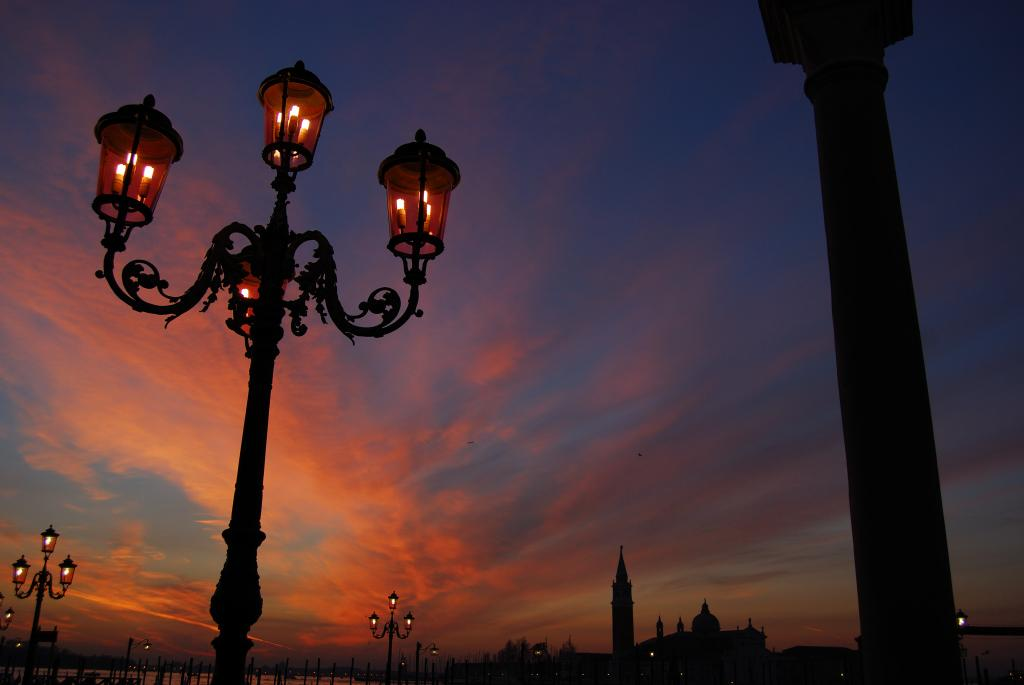What type of structures are present in the image? There are street lights with poles, a building, and a tower in the image. Where are these structures located in the image? The building and tower are at the bottom of the image, while the street lights are distributed throughout. What can be seen in the background of the image? The background of the image includes a cloudy sky. What type of pet can be seen writing a message on a piece of bread in the image? There is no pet or bread present in the image, and therefore no such activity can be observed. 